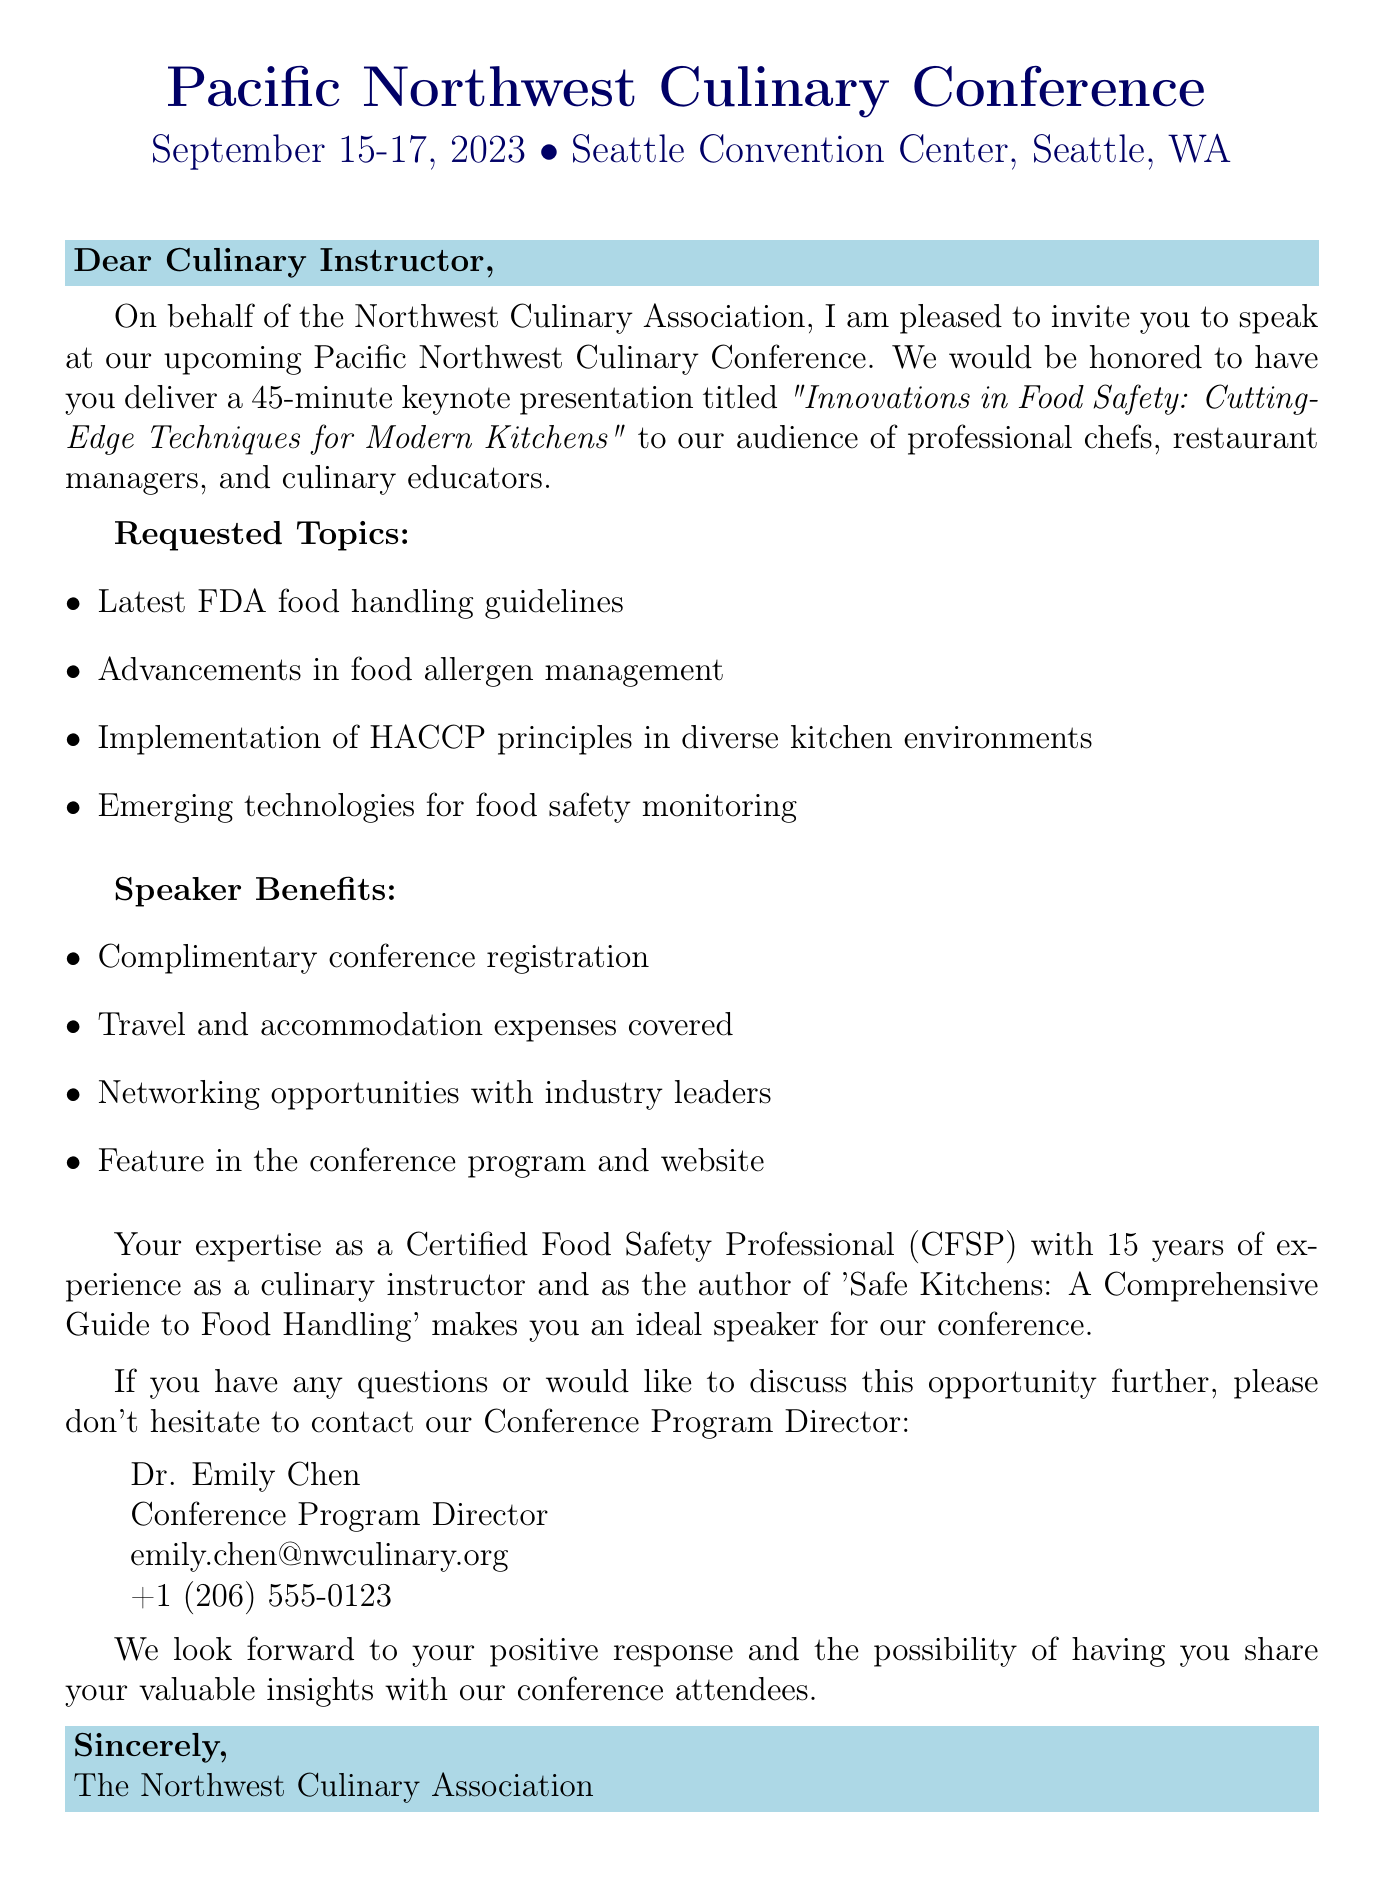What is the name of the conference? The name of the conference is explicitly stated in the document, which is the Pacific Northwest Culinary Conference.
Answer: Pacific Northwest Culinary Conference What are the dates of the event? The document provides the specific dates on which the event will take place, which are September 15-17, 2023.
Answer: September 15-17, 2023 Where is the conference located? The location of the event is mentioned in the document, specifically at Seattle Convention Center, Seattle, WA.
Answer: Seattle Convention Center, Seattle, WA What is the speaking slot duration? The length of the keynote presentation is clearly outlined in the document as a 45-minute speaking slot.
Answer: 45-minute Who is the contact person for the event? The document lists the contact person responsible for further queries regarding the conference, which is Dr. Emily Chen.
Answer: Dr. Emily Chen What is one of the requested topics for the presentation? The document specifies various topics, and one of them is the latest FDA food handling guidelines.
Answer: Latest FDA food handling guidelines What benefit do speakers receive regarding conference registration? The document mentions that speakers will receive complimentary conference registration as a benefit.
Answer: Complimentary conference registration What is the target audience for the keynote presentation? The document clearly identifies that the target audience includes professional chefs, restaurant managers, and culinary educators.
Answer: Professional chefs, restaurant managers, and culinary educators How many years of experience does the speaker have? The document states that the speaker has 15 years of experience as a culinary instructor.
Answer: 15 years 